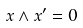<formula> <loc_0><loc_0><loc_500><loc_500>x \wedge x ^ { \prime } = 0</formula> 